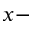<formula> <loc_0><loc_0><loc_500><loc_500>x -</formula> 